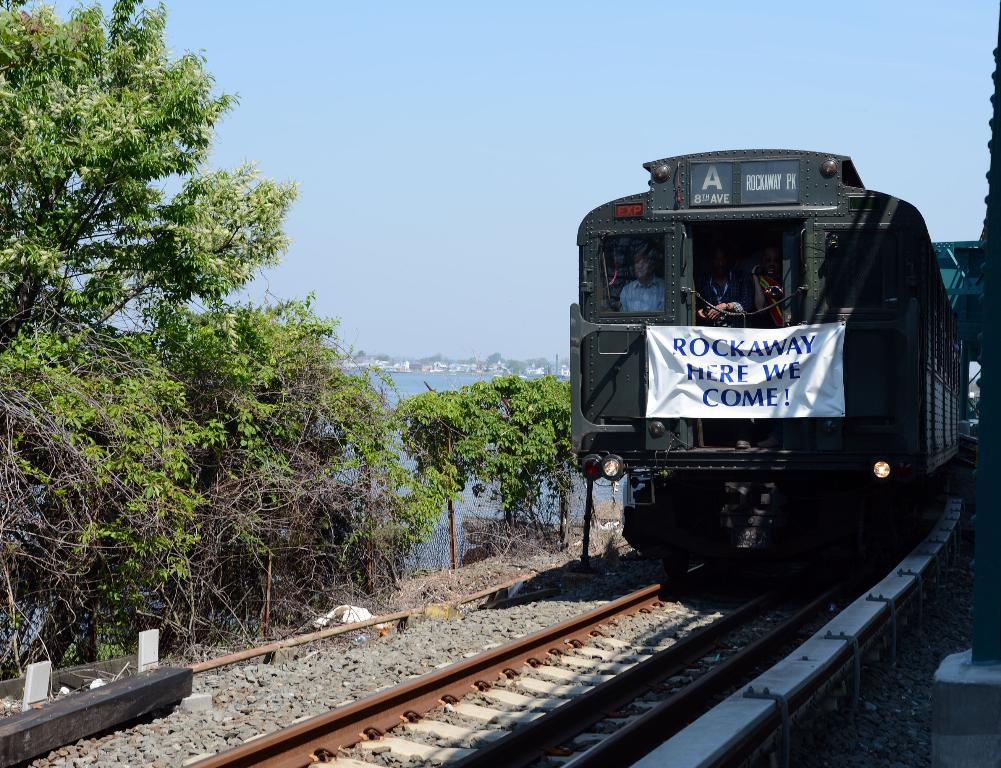Provide a one-sentence caption for the provided image. A train with a sign in front that reads "ROCKAWAY HERE WE COME!". 